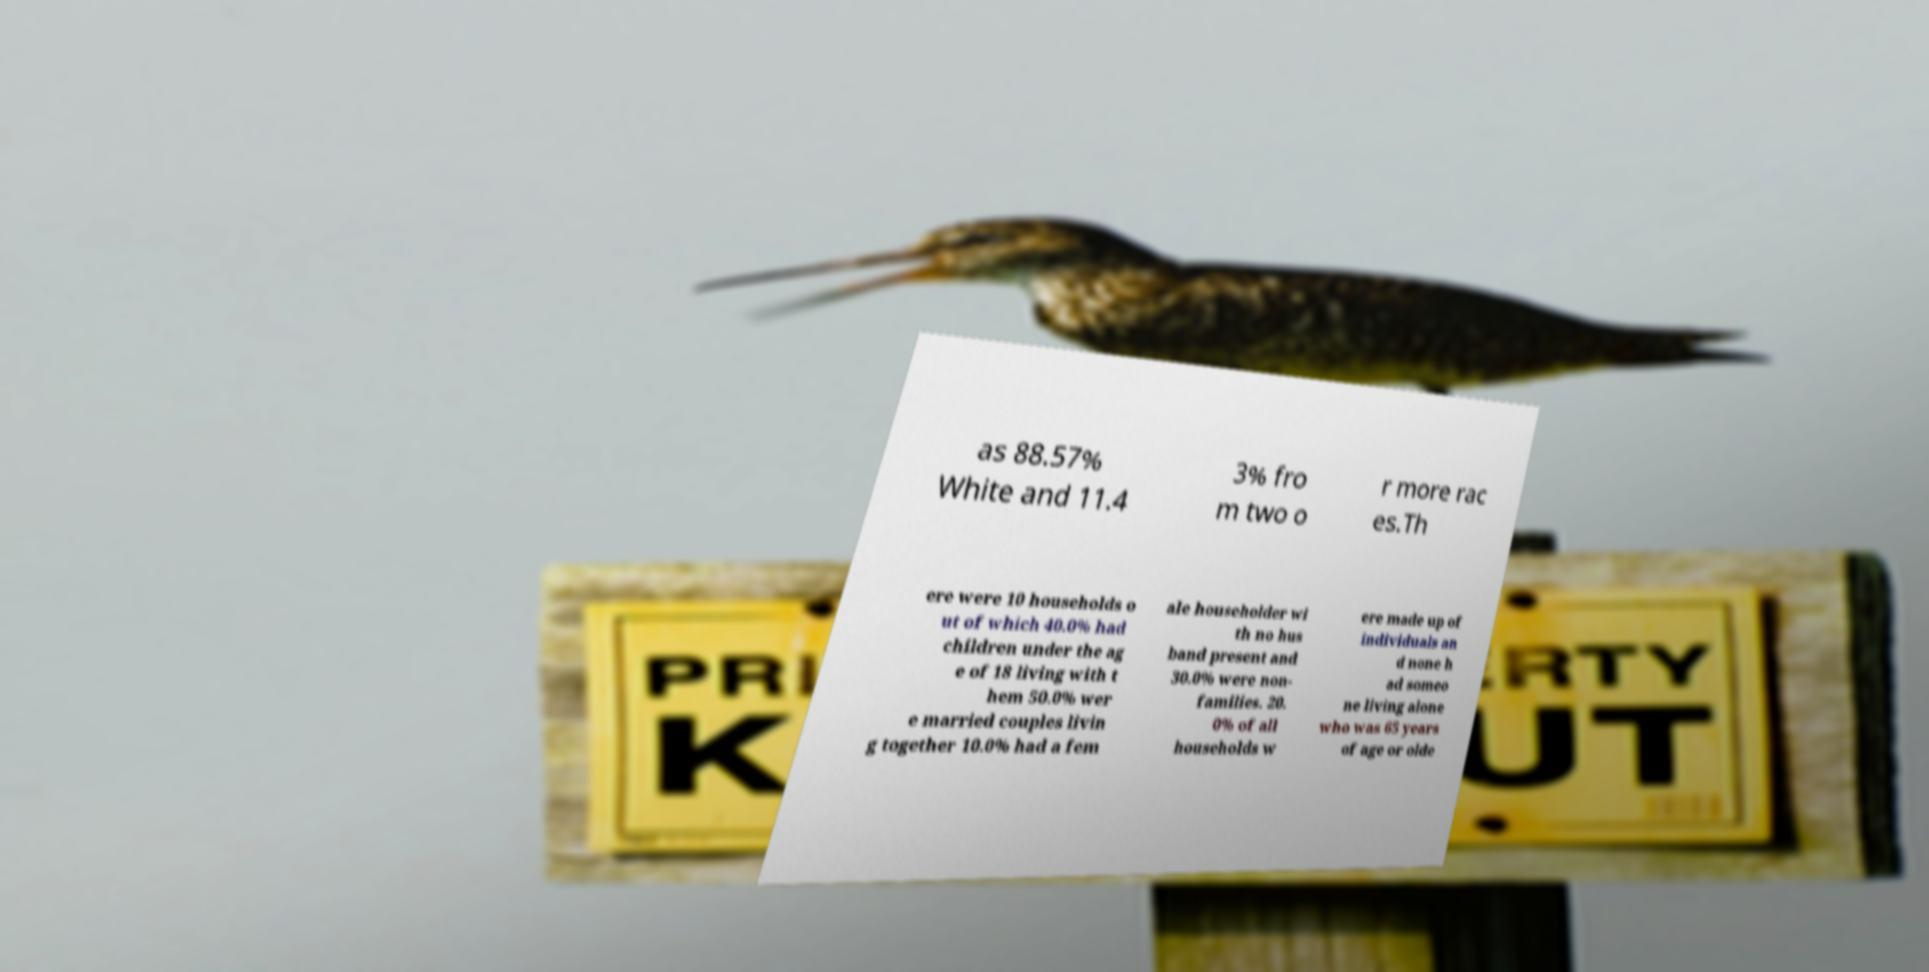Please identify and transcribe the text found in this image. as 88.57% White and 11.4 3% fro m two o r more rac es.Th ere were 10 households o ut of which 40.0% had children under the ag e of 18 living with t hem 50.0% wer e married couples livin g together 10.0% had a fem ale householder wi th no hus band present and 30.0% were non- families. 20. 0% of all households w ere made up of individuals an d none h ad someo ne living alone who was 65 years of age or olde 